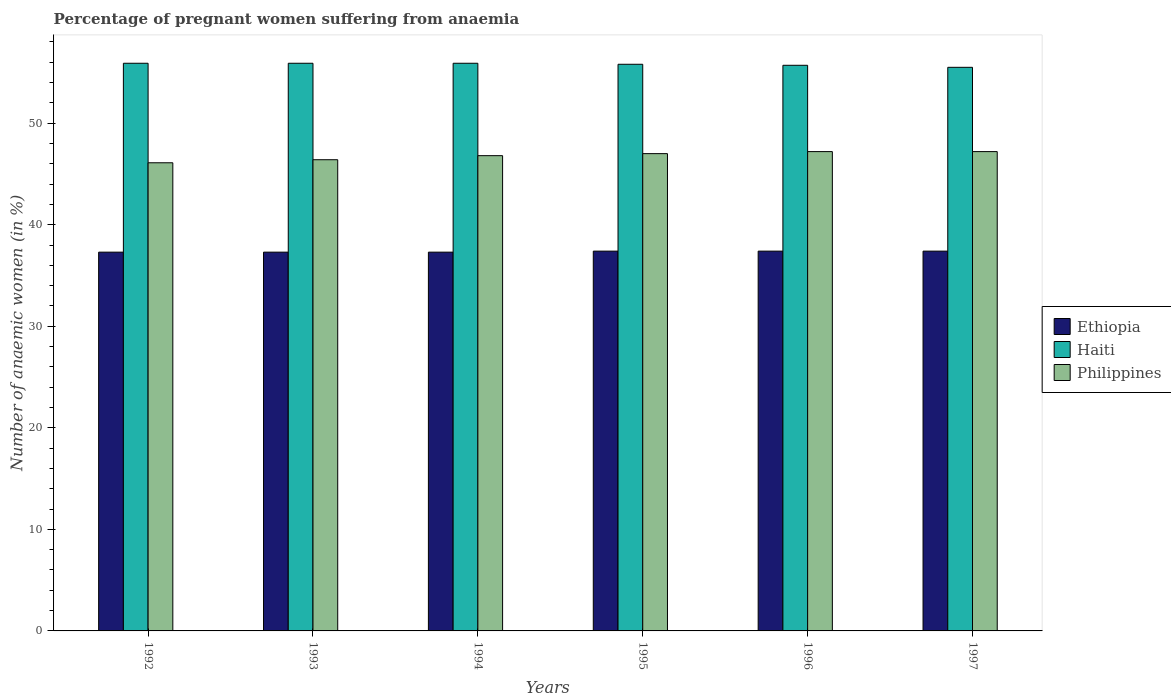How many groups of bars are there?
Make the answer very short. 6. What is the number of anaemic women in Haiti in 1994?
Offer a terse response. 55.9. Across all years, what is the maximum number of anaemic women in Ethiopia?
Your answer should be compact. 37.4. Across all years, what is the minimum number of anaemic women in Haiti?
Provide a succinct answer. 55.5. In which year was the number of anaemic women in Haiti maximum?
Make the answer very short. 1992. In which year was the number of anaemic women in Philippines minimum?
Provide a succinct answer. 1992. What is the total number of anaemic women in Ethiopia in the graph?
Offer a very short reply. 224.1. What is the difference between the number of anaemic women in Ethiopia in 1992 and that in 1997?
Give a very brief answer. -0.1. What is the difference between the number of anaemic women in Ethiopia in 1996 and the number of anaemic women in Haiti in 1995?
Keep it short and to the point. -18.4. What is the average number of anaemic women in Haiti per year?
Offer a very short reply. 55.78. In the year 1992, what is the difference between the number of anaemic women in Ethiopia and number of anaemic women in Haiti?
Your answer should be very brief. -18.6. In how many years, is the number of anaemic women in Haiti greater than 12 %?
Your answer should be very brief. 6. What is the ratio of the number of anaemic women in Philippines in 1995 to that in 1996?
Offer a terse response. 1. Is the difference between the number of anaemic women in Ethiopia in 1996 and 1997 greater than the difference between the number of anaemic women in Haiti in 1996 and 1997?
Make the answer very short. No. What is the difference between the highest and the lowest number of anaemic women in Haiti?
Offer a terse response. 0.4. In how many years, is the number of anaemic women in Philippines greater than the average number of anaemic women in Philippines taken over all years?
Your answer should be very brief. 4. Is the sum of the number of anaemic women in Haiti in 1993 and 1995 greater than the maximum number of anaemic women in Ethiopia across all years?
Ensure brevity in your answer.  Yes. What does the 3rd bar from the left in 1997 represents?
Ensure brevity in your answer.  Philippines. What does the 3rd bar from the right in 1995 represents?
Offer a very short reply. Ethiopia. Is it the case that in every year, the sum of the number of anaemic women in Haiti and number of anaemic women in Philippines is greater than the number of anaemic women in Ethiopia?
Provide a succinct answer. Yes. How many years are there in the graph?
Keep it short and to the point. 6. What is the difference between two consecutive major ticks on the Y-axis?
Make the answer very short. 10. Does the graph contain any zero values?
Ensure brevity in your answer.  No. How many legend labels are there?
Your answer should be very brief. 3. How are the legend labels stacked?
Your response must be concise. Vertical. What is the title of the graph?
Offer a very short reply. Percentage of pregnant women suffering from anaemia. What is the label or title of the Y-axis?
Give a very brief answer. Number of anaemic women (in %). What is the Number of anaemic women (in %) of Ethiopia in 1992?
Ensure brevity in your answer.  37.3. What is the Number of anaemic women (in %) of Haiti in 1992?
Keep it short and to the point. 55.9. What is the Number of anaemic women (in %) in Philippines in 1992?
Keep it short and to the point. 46.1. What is the Number of anaemic women (in %) in Ethiopia in 1993?
Provide a short and direct response. 37.3. What is the Number of anaemic women (in %) in Haiti in 1993?
Your answer should be very brief. 55.9. What is the Number of anaemic women (in %) in Philippines in 1993?
Your answer should be very brief. 46.4. What is the Number of anaemic women (in %) in Ethiopia in 1994?
Your answer should be compact. 37.3. What is the Number of anaemic women (in %) of Haiti in 1994?
Your answer should be compact. 55.9. What is the Number of anaemic women (in %) of Philippines in 1994?
Your answer should be compact. 46.8. What is the Number of anaemic women (in %) of Ethiopia in 1995?
Provide a succinct answer. 37.4. What is the Number of anaemic women (in %) in Haiti in 1995?
Provide a short and direct response. 55.8. What is the Number of anaemic women (in %) of Ethiopia in 1996?
Offer a very short reply. 37.4. What is the Number of anaemic women (in %) of Haiti in 1996?
Provide a succinct answer. 55.7. What is the Number of anaemic women (in %) of Philippines in 1996?
Your answer should be very brief. 47.2. What is the Number of anaemic women (in %) of Ethiopia in 1997?
Provide a succinct answer. 37.4. What is the Number of anaemic women (in %) of Haiti in 1997?
Your response must be concise. 55.5. What is the Number of anaemic women (in %) in Philippines in 1997?
Your answer should be compact. 47.2. Across all years, what is the maximum Number of anaemic women (in %) in Ethiopia?
Your answer should be very brief. 37.4. Across all years, what is the maximum Number of anaemic women (in %) of Haiti?
Keep it short and to the point. 55.9. Across all years, what is the maximum Number of anaemic women (in %) in Philippines?
Make the answer very short. 47.2. Across all years, what is the minimum Number of anaemic women (in %) in Ethiopia?
Provide a succinct answer. 37.3. Across all years, what is the minimum Number of anaemic women (in %) in Haiti?
Provide a succinct answer. 55.5. Across all years, what is the minimum Number of anaemic women (in %) of Philippines?
Your answer should be very brief. 46.1. What is the total Number of anaemic women (in %) of Ethiopia in the graph?
Ensure brevity in your answer.  224.1. What is the total Number of anaemic women (in %) in Haiti in the graph?
Provide a short and direct response. 334.7. What is the total Number of anaemic women (in %) of Philippines in the graph?
Give a very brief answer. 280.7. What is the difference between the Number of anaemic women (in %) in Ethiopia in 1992 and that in 1993?
Ensure brevity in your answer.  0. What is the difference between the Number of anaemic women (in %) in Haiti in 1992 and that in 1993?
Offer a terse response. 0. What is the difference between the Number of anaemic women (in %) of Philippines in 1992 and that in 1993?
Offer a terse response. -0.3. What is the difference between the Number of anaemic women (in %) in Philippines in 1992 and that in 1994?
Ensure brevity in your answer.  -0.7. What is the difference between the Number of anaemic women (in %) of Ethiopia in 1992 and that in 1995?
Offer a very short reply. -0.1. What is the difference between the Number of anaemic women (in %) in Haiti in 1992 and that in 1995?
Provide a short and direct response. 0.1. What is the difference between the Number of anaemic women (in %) of Ethiopia in 1992 and that in 1996?
Your answer should be very brief. -0.1. What is the difference between the Number of anaemic women (in %) in Ethiopia in 1992 and that in 1997?
Keep it short and to the point. -0.1. What is the difference between the Number of anaemic women (in %) of Philippines in 1992 and that in 1997?
Make the answer very short. -1.1. What is the difference between the Number of anaemic women (in %) of Ethiopia in 1993 and that in 1994?
Your answer should be compact. 0. What is the difference between the Number of anaemic women (in %) in Haiti in 1993 and that in 1995?
Provide a short and direct response. 0.1. What is the difference between the Number of anaemic women (in %) in Philippines in 1993 and that in 1995?
Your answer should be very brief. -0.6. What is the difference between the Number of anaemic women (in %) in Haiti in 1993 and that in 1997?
Ensure brevity in your answer.  0.4. What is the difference between the Number of anaemic women (in %) in Ethiopia in 1994 and that in 1995?
Your response must be concise. -0.1. What is the difference between the Number of anaemic women (in %) of Philippines in 1994 and that in 1995?
Keep it short and to the point. -0.2. What is the difference between the Number of anaemic women (in %) of Philippines in 1994 and that in 1996?
Provide a short and direct response. -0.4. What is the difference between the Number of anaemic women (in %) in Ethiopia in 1994 and that in 1997?
Your answer should be very brief. -0.1. What is the difference between the Number of anaemic women (in %) in Ethiopia in 1995 and that in 1997?
Offer a terse response. 0. What is the difference between the Number of anaemic women (in %) of Philippines in 1995 and that in 1997?
Ensure brevity in your answer.  -0.2. What is the difference between the Number of anaemic women (in %) of Haiti in 1996 and that in 1997?
Provide a short and direct response. 0.2. What is the difference between the Number of anaemic women (in %) of Ethiopia in 1992 and the Number of anaemic women (in %) of Haiti in 1993?
Your response must be concise. -18.6. What is the difference between the Number of anaemic women (in %) of Haiti in 1992 and the Number of anaemic women (in %) of Philippines in 1993?
Make the answer very short. 9.5. What is the difference between the Number of anaemic women (in %) in Ethiopia in 1992 and the Number of anaemic women (in %) in Haiti in 1994?
Make the answer very short. -18.6. What is the difference between the Number of anaemic women (in %) in Haiti in 1992 and the Number of anaemic women (in %) in Philippines in 1994?
Your answer should be very brief. 9.1. What is the difference between the Number of anaemic women (in %) in Ethiopia in 1992 and the Number of anaemic women (in %) in Haiti in 1995?
Give a very brief answer. -18.5. What is the difference between the Number of anaemic women (in %) in Ethiopia in 1992 and the Number of anaemic women (in %) in Haiti in 1996?
Make the answer very short. -18.4. What is the difference between the Number of anaemic women (in %) of Ethiopia in 1992 and the Number of anaemic women (in %) of Haiti in 1997?
Ensure brevity in your answer.  -18.2. What is the difference between the Number of anaemic women (in %) of Ethiopia in 1993 and the Number of anaemic women (in %) of Haiti in 1994?
Provide a succinct answer. -18.6. What is the difference between the Number of anaemic women (in %) of Ethiopia in 1993 and the Number of anaemic women (in %) of Haiti in 1995?
Your answer should be compact. -18.5. What is the difference between the Number of anaemic women (in %) of Haiti in 1993 and the Number of anaemic women (in %) of Philippines in 1995?
Give a very brief answer. 8.9. What is the difference between the Number of anaemic women (in %) in Ethiopia in 1993 and the Number of anaemic women (in %) in Haiti in 1996?
Provide a short and direct response. -18.4. What is the difference between the Number of anaemic women (in %) in Ethiopia in 1993 and the Number of anaemic women (in %) in Philippines in 1996?
Give a very brief answer. -9.9. What is the difference between the Number of anaemic women (in %) in Haiti in 1993 and the Number of anaemic women (in %) in Philippines in 1996?
Keep it short and to the point. 8.7. What is the difference between the Number of anaemic women (in %) of Ethiopia in 1993 and the Number of anaemic women (in %) of Haiti in 1997?
Ensure brevity in your answer.  -18.2. What is the difference between the Number of anaemic women (in %) of Haiti in 1993 and the Number of anaemic women (in %) of Philippines in 1997?
Provide a succinct answer. 8.7. What is the difference between the Number of anaemic women (in %) in Ethiopia in 1994 and the Number of anaemic women (in %) in Haiti in 1995?
Your response must be concise. -18.5. What is the difference between the Number of anaemic women (in %) of Ethiopia in 1994 and the Number of anaemic women (in %) of Philippines in 1995?
Your response must be concise. -9.7. What is the difference between the Number of anaemic women (in %) in Ethiopia in 1994 and the Number of anaemic women (in %) in Haiti in 1996?
Offer a terse response. -18.4. What is the difference between the Number of anaemic women (in %) of Ethiopia in 1994 and the Number of anaemic women (in %) of Philippines in 1996?
Provide a short and direct response. -9.9. What is the difference between the Number of anaemic women (in %) in Ethiopia in 1994 and the Number of anaemic women (in %) in Haiti in 1997?
Give a very brief answer. -18.2. What is the difference between the Number of anaemic women (in %) in Haiti in 1994 and the Number of anaemic women (in %) in Philippines in 1997?
Provide a succinct answer. 8.7. What is the difference between the Number of anaemic women (in %) of Ethiopia in 1995 and the Number of anaemic women (in %) of Haiti in 1996?
Ensure brevity in your answer.  -18.3. What is the difference between the Number of anaemic women (in %) of Ethiopia in 1995 and the Number of anaemic women (in %) of Haiti in 1997?
Keep it short and to the point. -18.1. What is the difference between the Number of anaemic women (in %) of Ethiopia in 1995 and the Number of anaemic women (in %) of Philippines in 1997?
Offer a terse response. -9.8. What is the difference between the Number of anaemic women (in %) of Ethiopia in 1996 and the Number of anaemic women (in %) of Haiti in 1997?
Your response must be concise. -18.1. What is the difference between the Number of anaemic women (in %) in Ethiopia in 1996 and the Number of anaemic women (in %) in Philippines in 1997?
Your answer should be very brief. -9.8. What is the difference between the Number of anaemic women (in %) of Haiti in 1996 and the Number of anaemic women (in %) of Philippines in 1997?
Provide a succinct answer. 8.5. What is the average Number of anaemic women (in %) in Ethiopia per year?
Give a very brief answer. 37.35. What is the average Number of anaemic women (in %) of Haiti per year?
Keep it short and to the point. 55.78. What is the average Number of anaemic women (in %) in Philippines per year?
Keep it short and to the point. 46.78. In the year 1992, what is the difference between the Number of anaemic women (in %) in Ethiopia and Number of anaemic women (in %) in Haiti?
Ensure brevity in your answer.  -18.6. In the year 1992, what is the difference between the Number of anaemic women (in %) of Ethiopia and Number of anaemic women (in %) of Philippines?
Offer a terse response. -8.8. In the year 1993, what is the difference between the Number of anaemic women (in %) of Ethiopia and Number of anaemic women (in %) of Haiti?
Make the answer very short. -18.6. In the year 1993, what is the difference between the Number of anaemic women (in %) of Ethiopia and Number of anaemic women (in %) of Philippines?
Ensure brevity in your answer.  -9.1. In the year 1993, what is the difference between the Number of anaemic women (in %) of Haiti and Number of anaemic women (in %) of Philippines?
Your answer should be compact. 9.5. In the year 1994, what is the difference between the Number of anaemic women (in %) in Ethiopia and Number of anaemic women (in %) in Haiti?
Offer a terse response. -18.6. In the year 1994, what is the difference between the Number of anaemic women (in %) in Ethiopia and Number of anaemic women (in %) in Philippines?
Your response must be concise. -9.5. In the year 1995, what is the difference between the Number of anaemic women (in %) of Ethiopia and Number of anaemic women (in %) of Haiti?
Offer a terse response. -18.4. In the year 1995, what is the difference between the Number of anaemic women (in %) in Haiti and Number of anaemic women (in %) in Philippines?
Offer a terse response. 8.8. In the year 1996, what is the difference between the Number of anaemic women (in %) in Ethiopia and Number of anaemic women (in %) in Haiti?
Offer a very short reply. -18.3. In the year 1996, what is the difference between the Number of anaemic women (in %) of Haiti and Number of anaemic women (in %) of Philippines?
Ensure brevity in your answer.  8.5. In the year 1997, what is the difference between the Number of anaemic women (in %) in Ethiopia and Number of anaemic women (in %) in Haiti?
Give a very brief answer. -18.1. In the year 1997, what is the difference between the Number of anaemic women (in %) in Ethiopia and Number of anaemic women (in %) in Philippines?
Offer a very short reply. -9.8. In the year 1997, what is the difference between the Number of anaemic women (in %) of Haiti and Number of anaemic women (in %) of Philippines?
Your response must be concise. 8.3. What is the ratio of the Number of anaemic women (in %) in Philippines in 1992 to that in 1993?
Offer a very short reply. 0.99. What is the ratio of the Number of anaemic women (in %) in Ethiopia in 1992 to that in 1995?
Ensure brevity in your answer.  1. What is the ratio of the Number of anaemic women (in %) of Philippines in 1992 to that in 1995?
Offer a very short reply. 0.98. What is the ratio of the Number of anaemic women (in %) in Haiti in 1992 to that in 1996?
Ensure brevity in your answer.  1. What is the ratio of the Number of anaemic women (in %) of Philippines in 1992 to that in 1996?
Provide a short and direct response. 0.98. What is the ratio of the Number of anaemic women (in %) in Ethiopia in 1992 to that in 1997?
Keep it short and to the point. 1. What is the ratio of the Number of anaemic women (in %) in Haiti in 1992 to that in 1997?
Ensure brevity in your answer.  1.01. What is the ratio of the Number of anaemic women (in %) in Philippines in 1992 to that in 1997?
Provide a succinct answer. 0.98. What is the ratio of the Number of anaemic women (in %) of Ethiopia in 1993 to that in 1994?
Make the answer very short. 1. What is the ratio of the Number of anaemic women (in %) in Philippines in 1993 to that in 1994?
Provide a short and direct response. 0.99. What is the ratio of the Number of anaemic women (in %) in Philippines in 1993 to that in 1995?
Offer a terse response. 0.99. What is the ratio of the Number of anaemic women (in %) in Ethiopia in 1993 to that in 1996?
Your response must be concise. 1. What is the ratio of the Number of anaemic women (in %) of Haiti in 1993 to that in 1996?
Keep it short and to the point. 1. What is the ratio of the Number of anaemic women (in %) in Philippines in 1993 to that in 1996?
Offer a terse response. 0.98. What is the ratio of the Number of anaemic women (in %) in Ethiopia in 1993 to that in 1997?
Keep it short and to the point. 1. What is the ratio of the Number of anaemic women (in %) in Philippines in 1993 to that in 1997?
Make the answer very short. 0.98. What is the ratio of the Number of anaemic women (in %) of Ethiopia in 1994 to that in 1995?
Keep it short and to the point. 1. What is the ratio of the Number of anaemic women (in %) in Haiti in 1994 to that in 1995?
Offer a very short reply. 1. What is the ratio of the Number of anaemic women (in %) of Haiti in 1994 to that in 1997?
Provide a short and direct response. 1.01. What is the ratio of the Number of anaemic women (in %) in Ethiopia in 1995 to that in 1996?
Your answer should be compact. 1. What is the ratio of the Number of anaemic women (in %) in Haiti in 1995 to that in 1996?
Your response must be concise. 1. What is the ratio of the Number of anaemic women (in %) of Philippines in 1995 to that in 1996?
Offer a very short reply. 1. What is the ratio of the Number of anaemic women (in %) in Ethiopia in 1995 to that in 1997?
Make the answer very short. 1. What is the ratio of the Number of anaemic women (in %) in Haiti in 1995 to that in 1997?
Your response must be concise. 1.01. What is the ratio of the Number of anaemic women (in %) in Philippines in 1995 to that in 1997?
Keep it short and to the point. 1. What is the ratio of the Number of anaemic women (in %) in Ethiopia in 1996 to that in 1997?
Your response must be concise. 1. What is the ratio of the Number of anaemic women (in %) in Philippines in 1996 to that in 1997?
Offer a terse response. 1. What is the difference between the highest and the second highest Number of anaemic women (in %) in Haiti?
Your answer should be compact. 0. What is the difference between the highest and the second highest Number of anaemic women (in %) of Philippines?
Keep it short and to the point. 0. What is the difference between the highest and the lowest Number of anaemic women (in %) of Ethiopia?
Make the answer very short. 0.1. What is the difference between the highest and the lowest Number of anaemic women (in %) of Haiti?
Offer a very short reply. 0.4. What is the difference between the highest and the lowest Number of anaemic women (in %) of Philippines?
Your response must be concise. 1.1. 